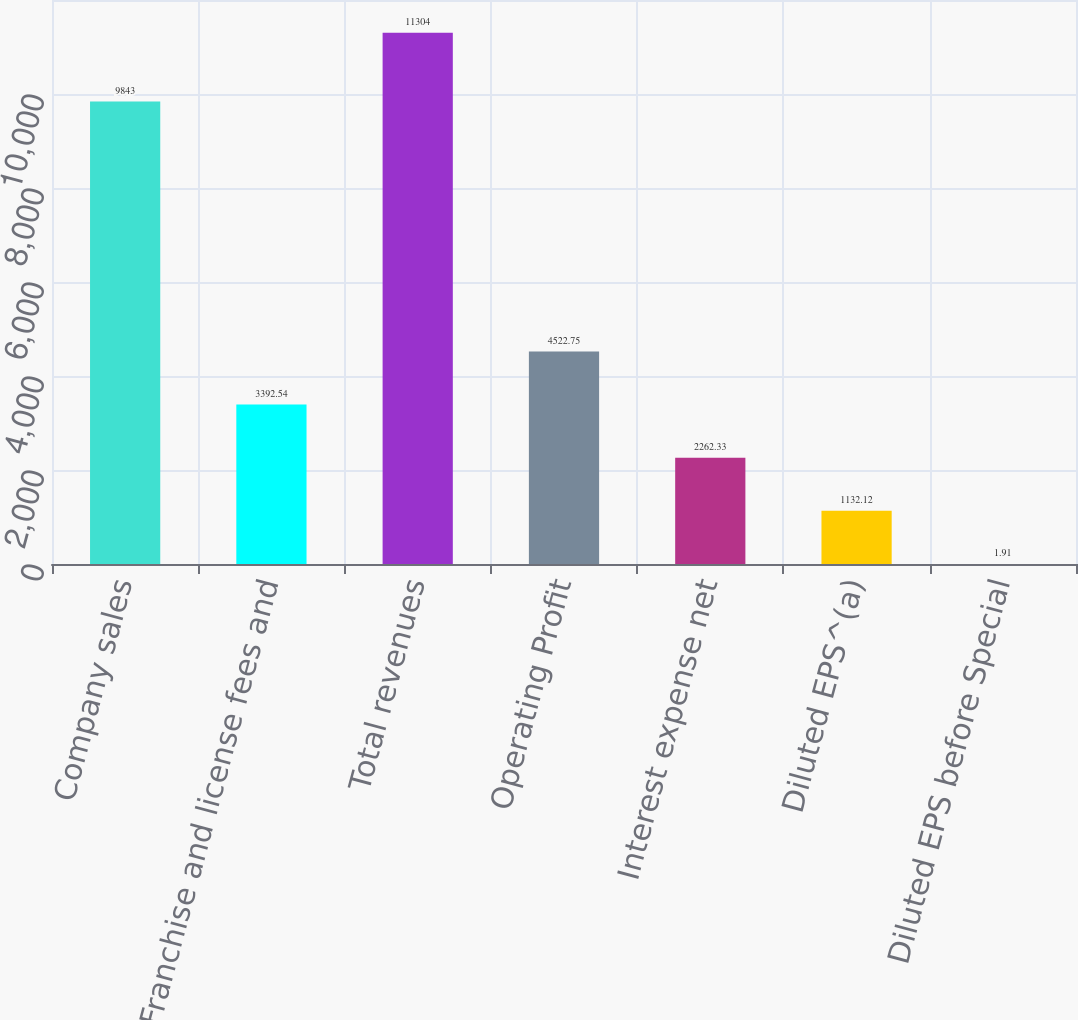Convert chart. <chart><loc_0><loc_0><loc_500><loc_500><bar_chart><fcel>Company sales<fcel>Franchise and license fees and<fcel>Total revenues<fcel>Operating Profit<fcel>Interest expense net<fcel>Diluted EPS^(a)<fcel>Diluted EPS before Special<nl><fcel>9843<fcel>3392.54<fcel>11304<fcel>4522.75<fcel>2262.33<fcel>1132.12<fcel>1.91<nl></chart> 